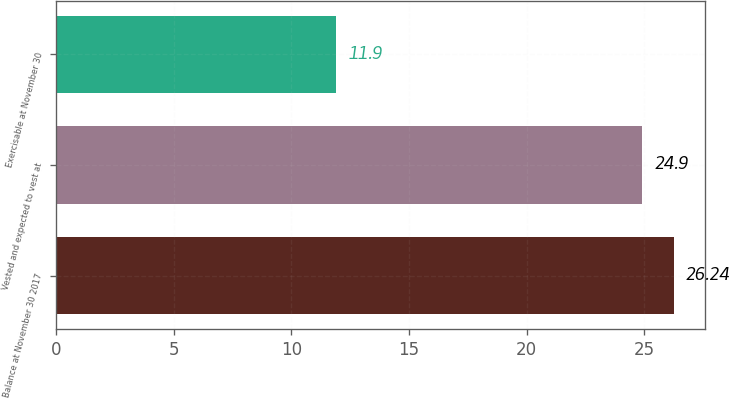Convert chart to OTSL. <chart><loc_0><loc_0><loc_500><loc_500><bar_chart><fcel>Balance at November 30 2017<fcel>Vested and expected to vest at<fcel>Exercisable at November 30<nl><fcel>26.24<fcel>24.9<fcel>11.9<nl></chart> 